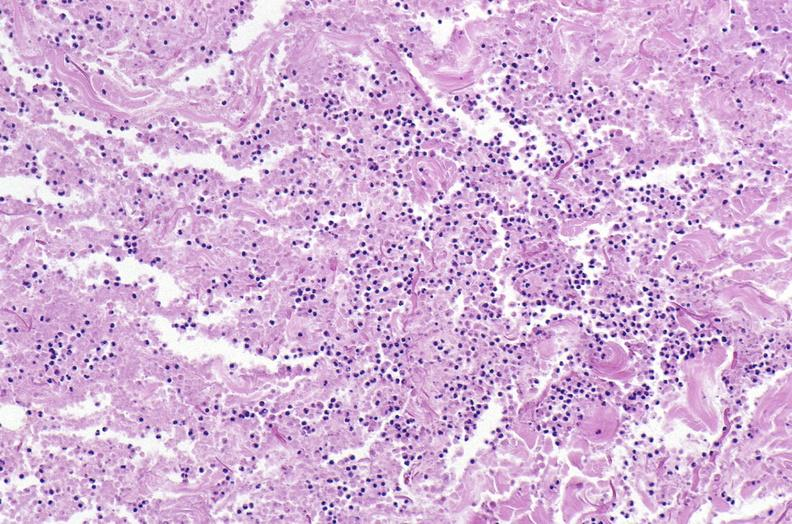what does this image show?
Answer the question using a single word or phrase. Panniculitis and fascitis 